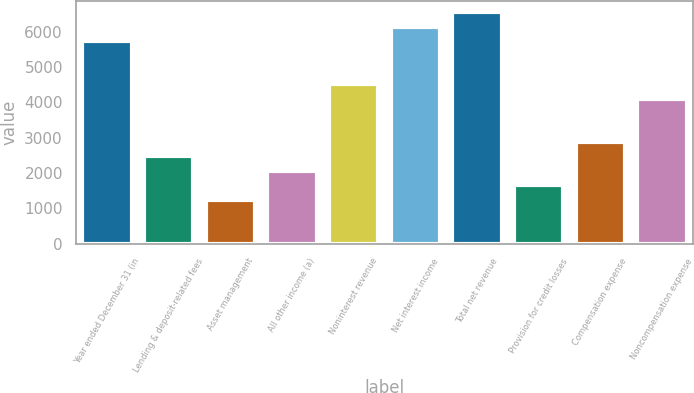<chart> <loc_0><loc_0><loc_500><loc_500><bar_chart><fcel>Year ended December 31 (in<fcel>Lending & deposit-related fees<fcel>Asset management<fcel>All other income (a)<fcel>Noninterest revenue<fcel>Net interest income<fcel>Total net revenue<fcel>Provision for credit losses<fcel>Compensation expense<fcel>Noncompensation expense<nl><fcel>5737.4<fcel>2468.6<fcel>1242.8<fcel>2060<fcel>4511.6<fcel>6146<fcel>6554.6<fcel>1651.4<fcel>2877.2<fcel>4103<nl></chart> 